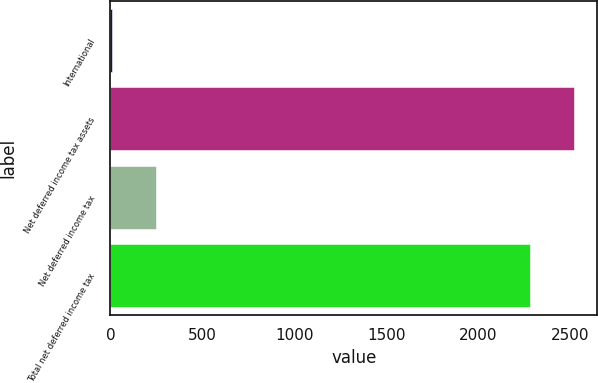Convert chart to OTSL. <chart><loc_0><loc_0><loc_500><loc_500><bar_chart><fcel>International<fcel>Net deferred income tax assets<fcel>Net deferred income tax<fcel>Total net deferred income tax<nl><fcel>10.5<fcel>2520.2<fcel>248<fcel>2282.7<nl></chart> 